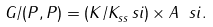Convert formula to latex. <formula><loc_0><loc_0><loc_500><loc_500>G / ( P , P ) = ( K / K _ { s s } ^ { \ } s i ) \times A _ { \ } s i .</formula> 